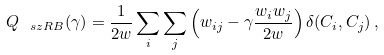<formula> <loc_0><loc_0><loc_500><loc_500>Q _ { \ s z R B } ( \gamma ) = \frac { 1 } { 2 w } \sum _ { i } \sum _ { j } \left ( w _ { i j } - \gamma \frac { w _ { i } w _ { j } } { 2 w } \right ) \delta ( C _ { i } , C _ { j } ) \, ,</formula> 